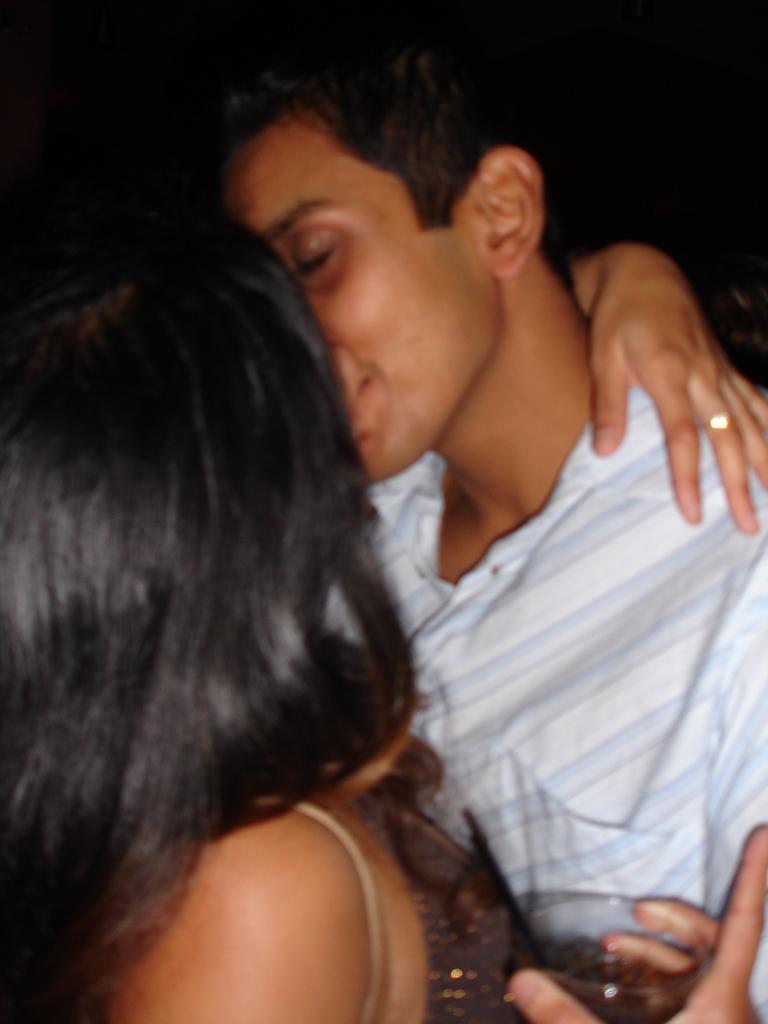In one or two sentences, can you explain what this image depicts? In this image we can see two persons kissing. Among them a person is holding a glass. The background of the image is dark. 